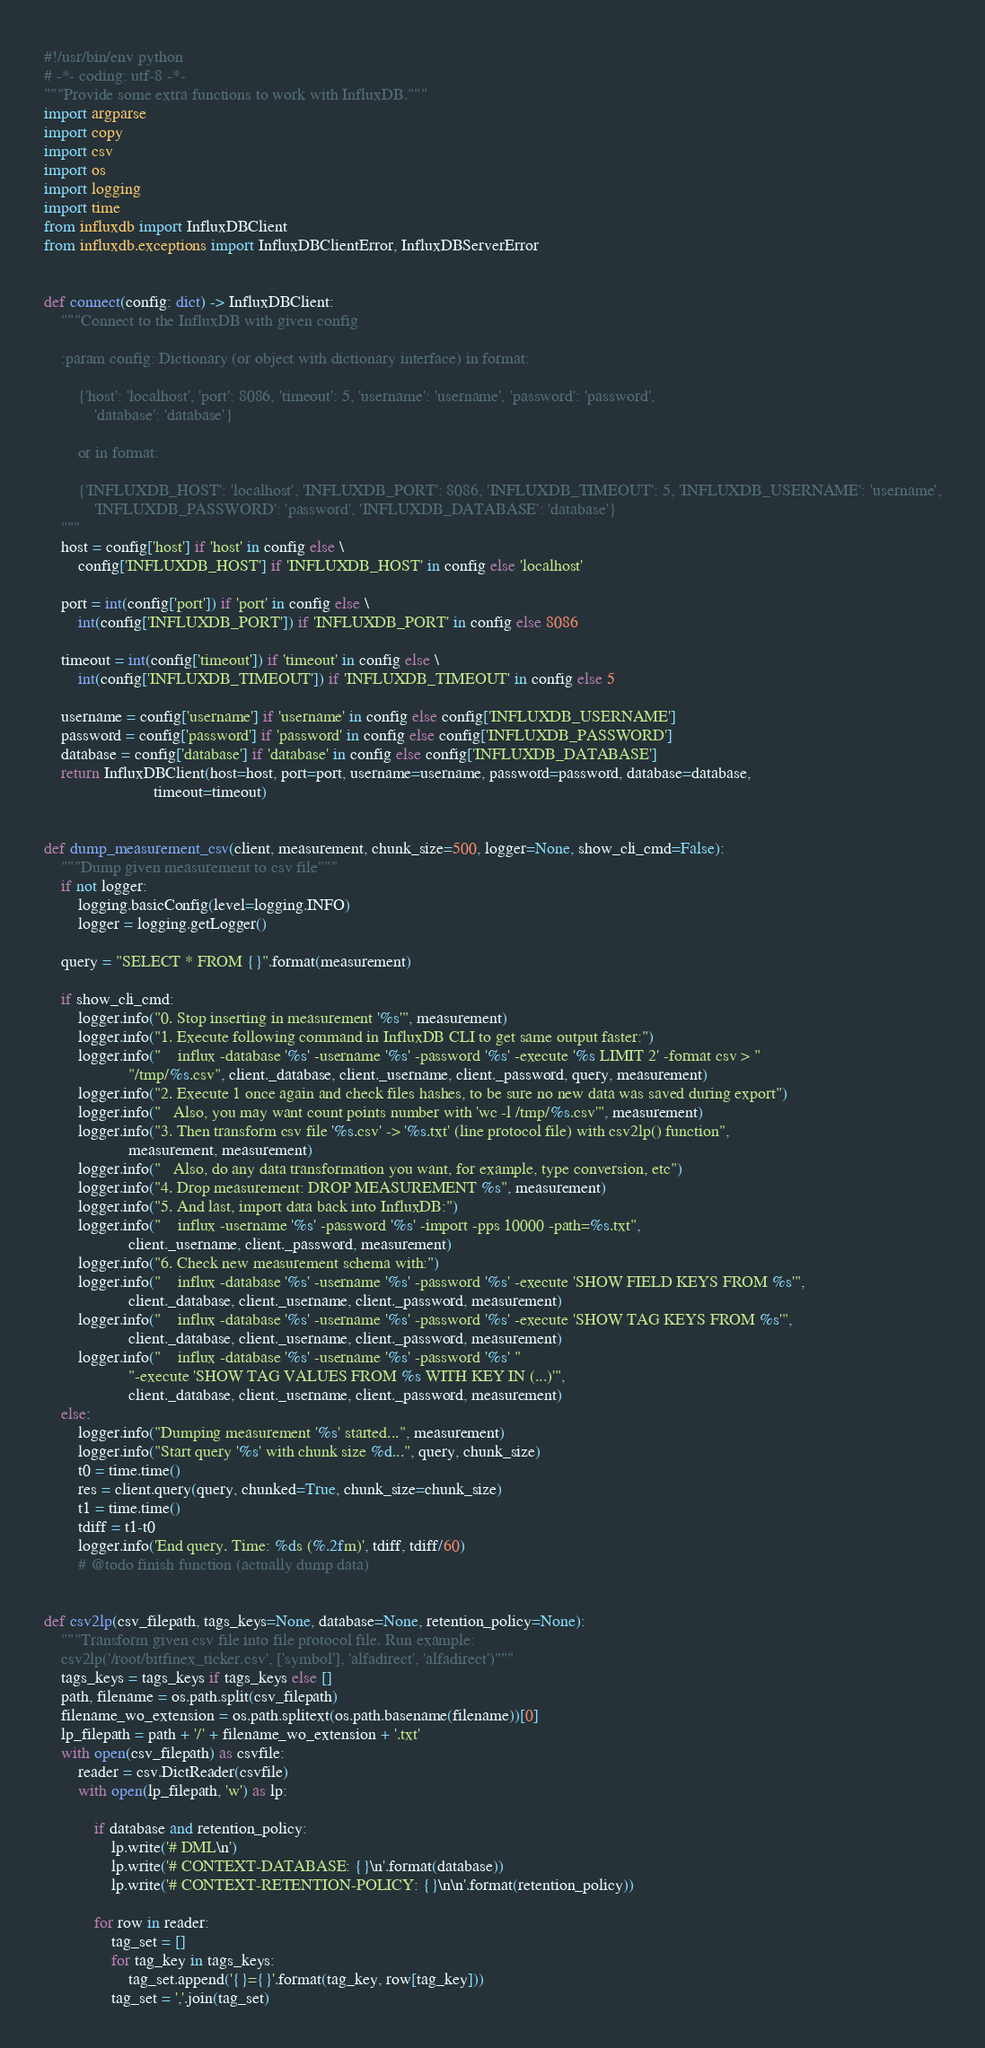<code> <loc_0><loc_0><loc_500><loc_500><_Python_>#!/usr/bin/env python
# -*- coding: utf-8 -*-
"""Provide some extra functions to work with InfluxDB."""
import argparse
import copy
import csv
import os
import logging
import time
from influxdb import InfluxDBClient
from influxdb.exceptions import InfluxDBClientError, InfluxDBServerError


def connect(config: dict) -> InfluxDBClient:
    """Connect to the InfluxDB with given config

    :param config: Dictionary (or object with dictionary interface) in format:

        {'host': 'localhost', 'port': 8086, 'timeout': 5, 'username': 'username', 'password': 'password',
            'database': 'database'}

        or in format:

        {'INFLUXDB_HOST': 'localhost', 'INFLUXDB_PORT': 8086, 'INFLUXDB_TIMEOUT': 5, 'INFLUXDB_USERNAME': 'username',
            'INFLUXDB_PASSWORD': 'password', 'INFLUXDB_DATABASE': 'database'}
    """
    host = config['host'] if 'host' in config else \
        config['INFLUXDB_HOST'] if 'INFLUXDB_HOST' in config else 'localhost'

    port = int(config['port']) if 'port' in config else \
        int(config['INFLUXDB_PORT']) if 'INFLUXDB_PORT' in config else 8086

    timeout = int(config['timeout']) if 'timeout' in config else \
        int(config['INFLUXDB_TIMEOUT']) if 'INFLUXDB_TIMEOUT' in config else 5

    username = config['username'] if 'username' in config else config['INFLUXDB_USERNAME']
    password = config['password'] if 'password' in config else config['INFLUXDB_PASSWORD']
    database = config['database'] if 'database' in config else config['INFLUXDB_DATABASE']
    return InfluxDBClient(host=host, port=port, username=username, password=password, database=database,
                          timeout=timeout)


def dump_measurement_csv(client, measurement, chunk_size=500, logger=None, show_cli_cmd=False):
    """Dump given measurement to csv file"""
    if not logger:
        logging.basicConfig(level=logging.INFO)
        logger = logging.getLogger()

    query = "SELECT * FROM {}".format(measurement)

    if show_cli_cmd:
        logger.info("0. Stop inserting in measurement '%s'", measurement)
        logger.info("1. Execute following command in InfluxDB CLI to get same output faster:")
        logger.info("    influx -database '%s' -username '%s' -password '%s' -execute '%s LIMIT 2' -format csv > "
                    "/tmp/%s.csv", client._database, client._username, client._password, query, measurement)
        logger.info("2. Execute 1 once again and check files hashes, to be sure no new data was saved during export")
        logger.info("   Also, you may want count points number with 'wc -l /tmp/%s.csv'", measurement)
        logger.info("3. Then transform csv file '%s.csv' -> '%s.txt' (line protocol file) with csv2lp() function",
                    measurement, measurement)
        logger.info("   Also, do any data transformation you want, for example, type conversion, etc")
        logger.info("4. Drop measurement: DROP MEASUREMENT %s", measurement)
        logger.info("5. And last, import data back into InfluxDB:")
        logger.info("    influx -username '%s' -password '%s' -import -pps 10000 -path=%s.txt",
                    client._username, client._password, measurement)
        logger.info("6. Check new measurement schema with:")
        logger.info("    influx -database '%s' -username '%s' -password '%s' -execute 'SHOW FIELD KEYS FROM %s'",
                    client._database, client._username, client._password, measurement)
        logger.info("    influx -database '%s' -username '%s' -password '%s' -execute 'SHOW TAG KEYS FROM %s'",
                    client._database, client._username, client._password, measurement)
        logger.info("    influx -database '%s' -username '%s' -password '%s' "
                    "-execute 'SHOW TAG VALUES FROM %s WITH KEY IN (...)'",
                    client._database, client._username, client._password, measurement)
    else:
        logger.info("Dumping measurement '%s' started...", measurement)
        logger.info("Start query '%s' with chunk size %d...", query, chunk_size)
        t0 = time.time()
        res = client.query(query, chunked=True, chunk_size=chunk_size)
        t1 = time.time()
        tdiff = t1-t0
        logger.info('End query. Time: %ds (%.2fm)', tdiff, tdiff/60)
        # @todo finish function (actually dump data)


def csv2lp(csv_filepath, tags_keys=None, database=None, retention_policy=None):
    """Transform given csv file into file protocol file. Run example:
    csv2lp('/root/bitfinex_ticker.csv', ['symbol'], 'alfadirect', 'alfadirect')"""
    tags_keys = tags_keys if tags_keys else []
    path, filename = os.path.split(csv_filepath)
    filename_wo_extension = os.path.splitext(os.path.basename(filename))[0]
    lp_filepath = path + '/' + filename_wo_extension + '.txt'
    with open(csv_filepath) as csvfile:
        reader = csv.DictReader(csvfile)
        with open(lp_filepath, 'w') as lp:

            if database and retention_policy:
                lp.write('# DML\n')
                lp.write('# CONTEXT-DATABASE: {}\n'.format(database))
                lp.write('# CONTEXT-RETENTION-POLICY: {}\n\n'.format(retention_policy))

            for row in reader:
                tag_set = []
                for tag_key in tags_keys:
                    tag_set.append('{}={}'.format(tag_key, row[tag_key]))
                tag_set = ','.join(tag_set)
</code> 